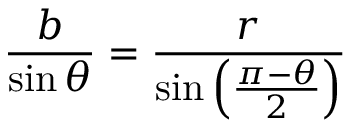<formula> <loc_0><loc_0><loc_500><loc_500>{ \frac { b } { \sin \theta } } = { \frac { r } { \sin \left ( { \frac { \pi - \theta } { 2 } } \right ) } }</formula> 